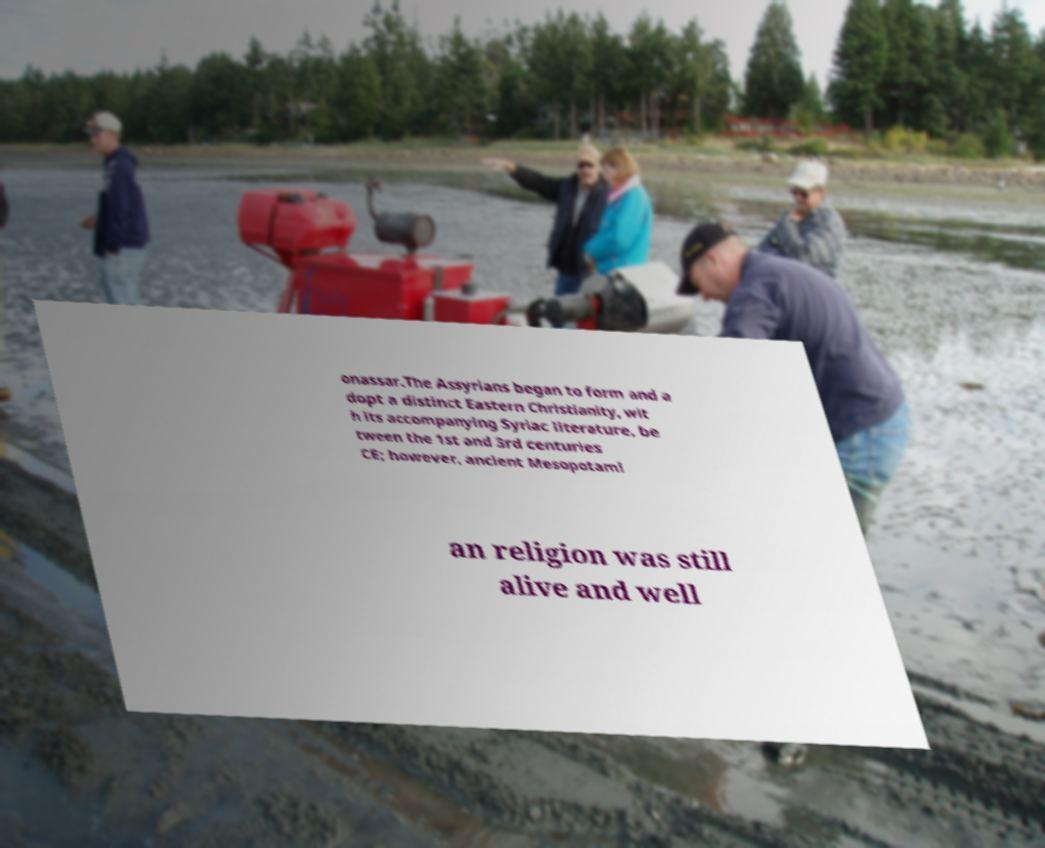Please read and relay the text visible in this image. What does it say? onassar.The Assyrians began to form and a dopt a distinct Eastern Christianity, wit h its accompanying Syriac literature, be tween the 1st and 3rd centuries CE; however, ancient Mesopotami an religion was still alive and well 